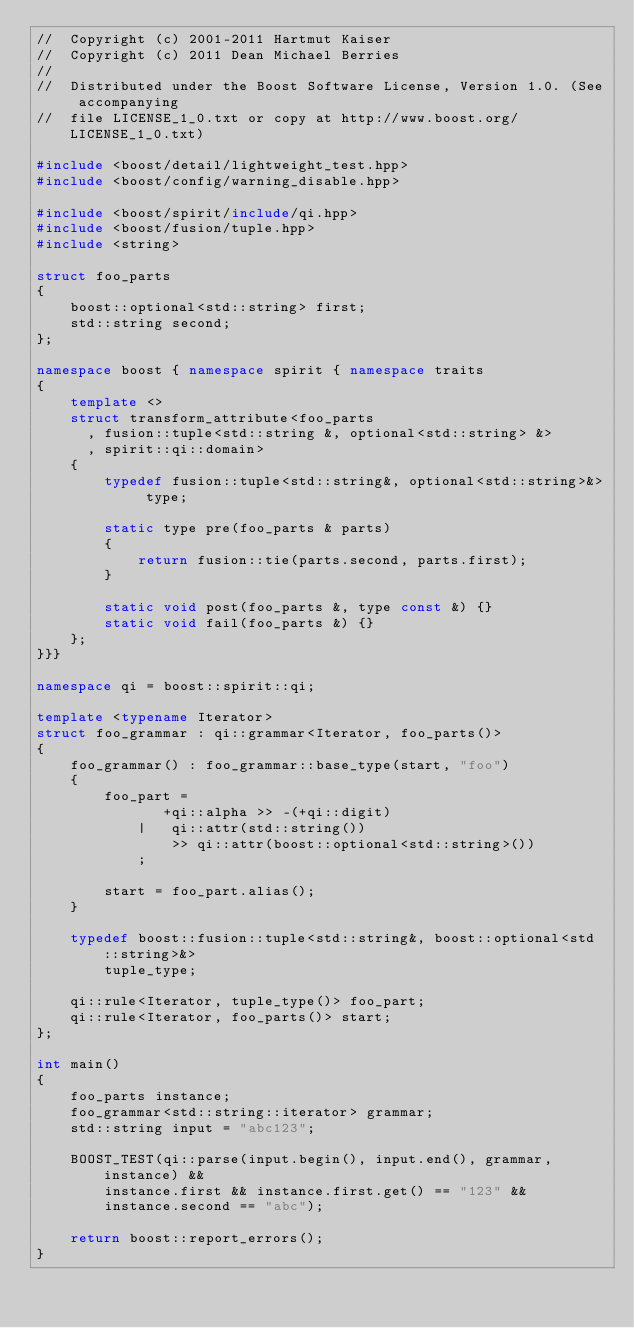<code> <loc_0><loc_0><loc_500><loc_500><_C++_>//  Copyright (c) 2001-2011 Hartmut Kaiser
//  Copyright (c) 2011 Dean Michael Berries
// 
//  Distributed under the Boost Software License, Version 1.0. (See accompanying 
//  file LICENSE_1_0.txt or copy at http://www.boost.org/LICENSE_1_0.txt)

#include <boost/detail/lightweight_test.hpp>
#include <boost/config/warning_disable.hpp>

#include <boost/spirit/include/qi.hpp>
#include <boost/fusion/tuple.hpp>
#include <string>

struct foo_parts 
{
    boost::optional<std::string> first;
    std::string second;
};

namespace boost { namespace spirit { namespace traits 
{
    template <>
    struct transform_attribute<foo_parts
      , fusion::tuple<std::string &, optional<std::string> &>
      , spirit::qi::domain>
    {
        typedef fusion::tuple<std::string&, optional<std::string>&> type;

        static type pre(foo_parts & parts) 
        {
            return fusion::tie(parts.second, parts.first);
        }

        static void post(foo_parts &, type const &) {}
        static void fail(foo_parts &) {}
    };
}}}    

namespace qi = boost::spirit::qi;

template <typename Iterator>
struct foo_grammar : qi::grammar<Iterator, foo_parts()> 
{
    foo_grammar() : foo_grammar::base_type(start, "foo") 
    {
        foo_part = 
               +qi::alpha >> -(+qi::digit)
            |   qi::attr(std::string()) 
                >> qi::attr(boost::optional<std::string>())
            ;

        start = foo_part.alias();
    }

    typedef boost::fusion::tuple<std::string&, boost::optional<std::string>&>
        tuple_type;

    qi::rule<Iterator, tuple_type()> foo_part;
    qi::rule<Iterator, foo_parts()> start;
};

int main() 
{
    foo_parts instance;
    foo_grammar<std::string::iterator> grammar;
    std::string input = "abc123";
    
    BOOST_TEST(qi::parse(input.begin(), input.end(), grammar, instance) &&
        instance.first && instance.first.get() == "123" && 
        instance.second == "abc");

    return boost::report_errors();
}

</code> 